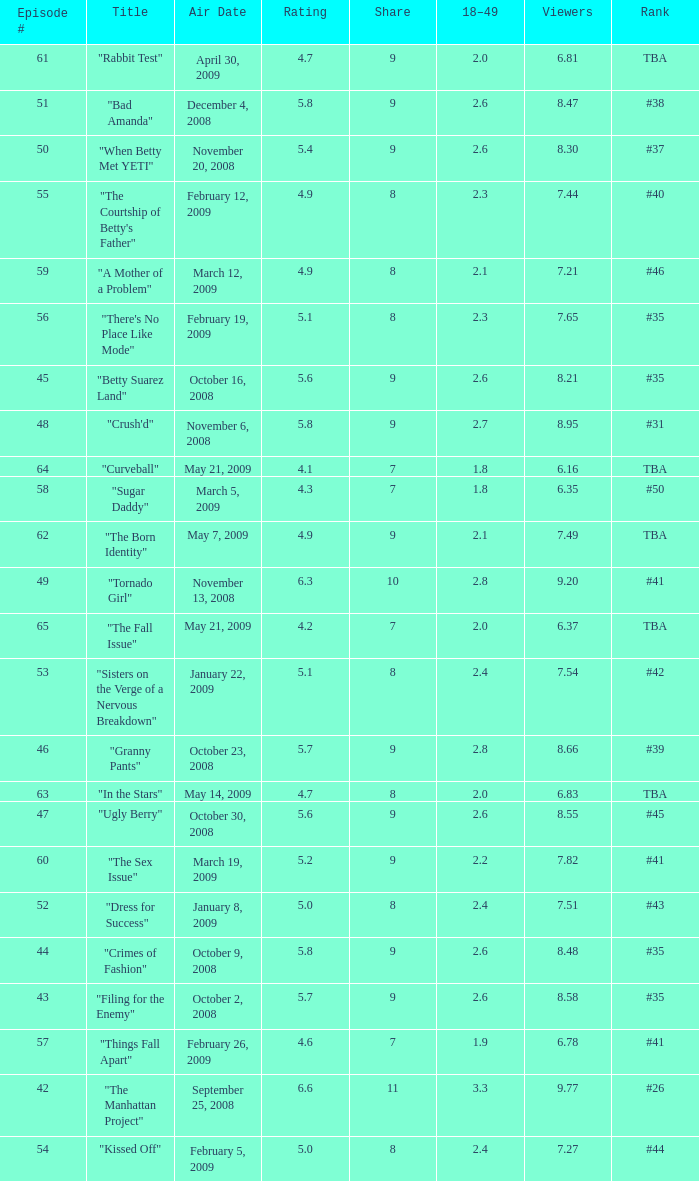What is the Air Date that has a 18–49 larger than 1.9, less than 7.54 viewers and a rating less than 4.9? April 30, 2009, May 14, 2009, May 21, 2009. 